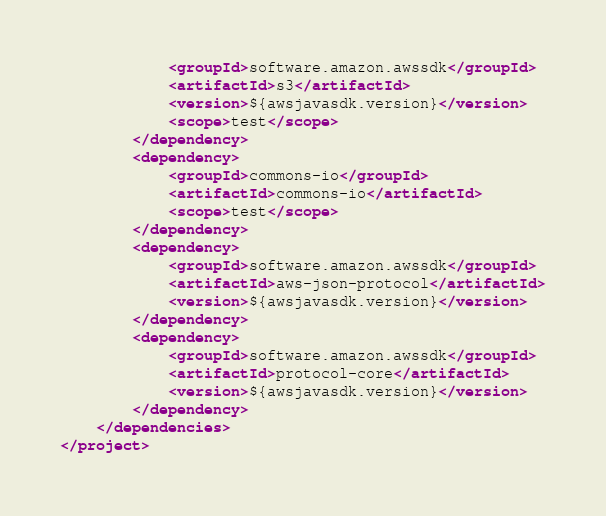<code> <loc_0><loc_0><loc_500><loc_500><_XML_>            <groupId>software.amazon.awssdk</groupId>
            <artifactId>s3</artifactId>
            <version>${awsjavasdk.version}</version>
            <scope>test</scope>
        </dependency>
        <dependency>
            <groupId>commons-io</groupId>
            <artifactId>commons-io</artifactId>
            <scope>test</scope>
        </dependency>
        <dependency>
            <groupId>software.amazon.awssdk</groupId>
            <artifactId>aws-json-protocol</artifactId>
            <version>${awsjavasdk.version}</version>
        </dependency>
        <dependency>
            <groupId>software.amazon.awssdk</groupId>
            <artifactId>protocol-core</artifactId>
            <version>${awsjavasdk.version}</version>
        </dependency>
    </dependencies>
</project>
</code> 